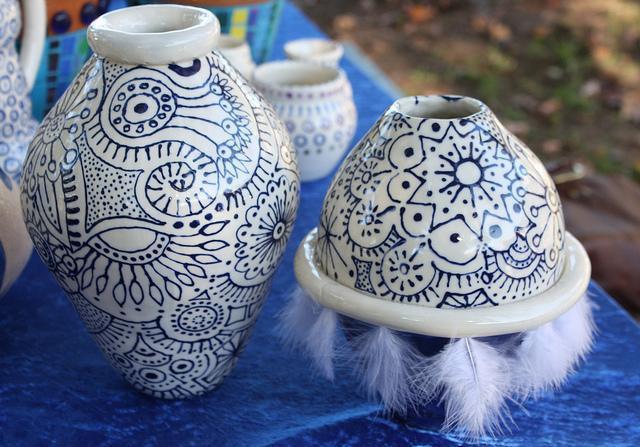How many vases can be seen?
Give a very brief answer. 4. How many people are sitting down?
Give a very brief answer. 0. 